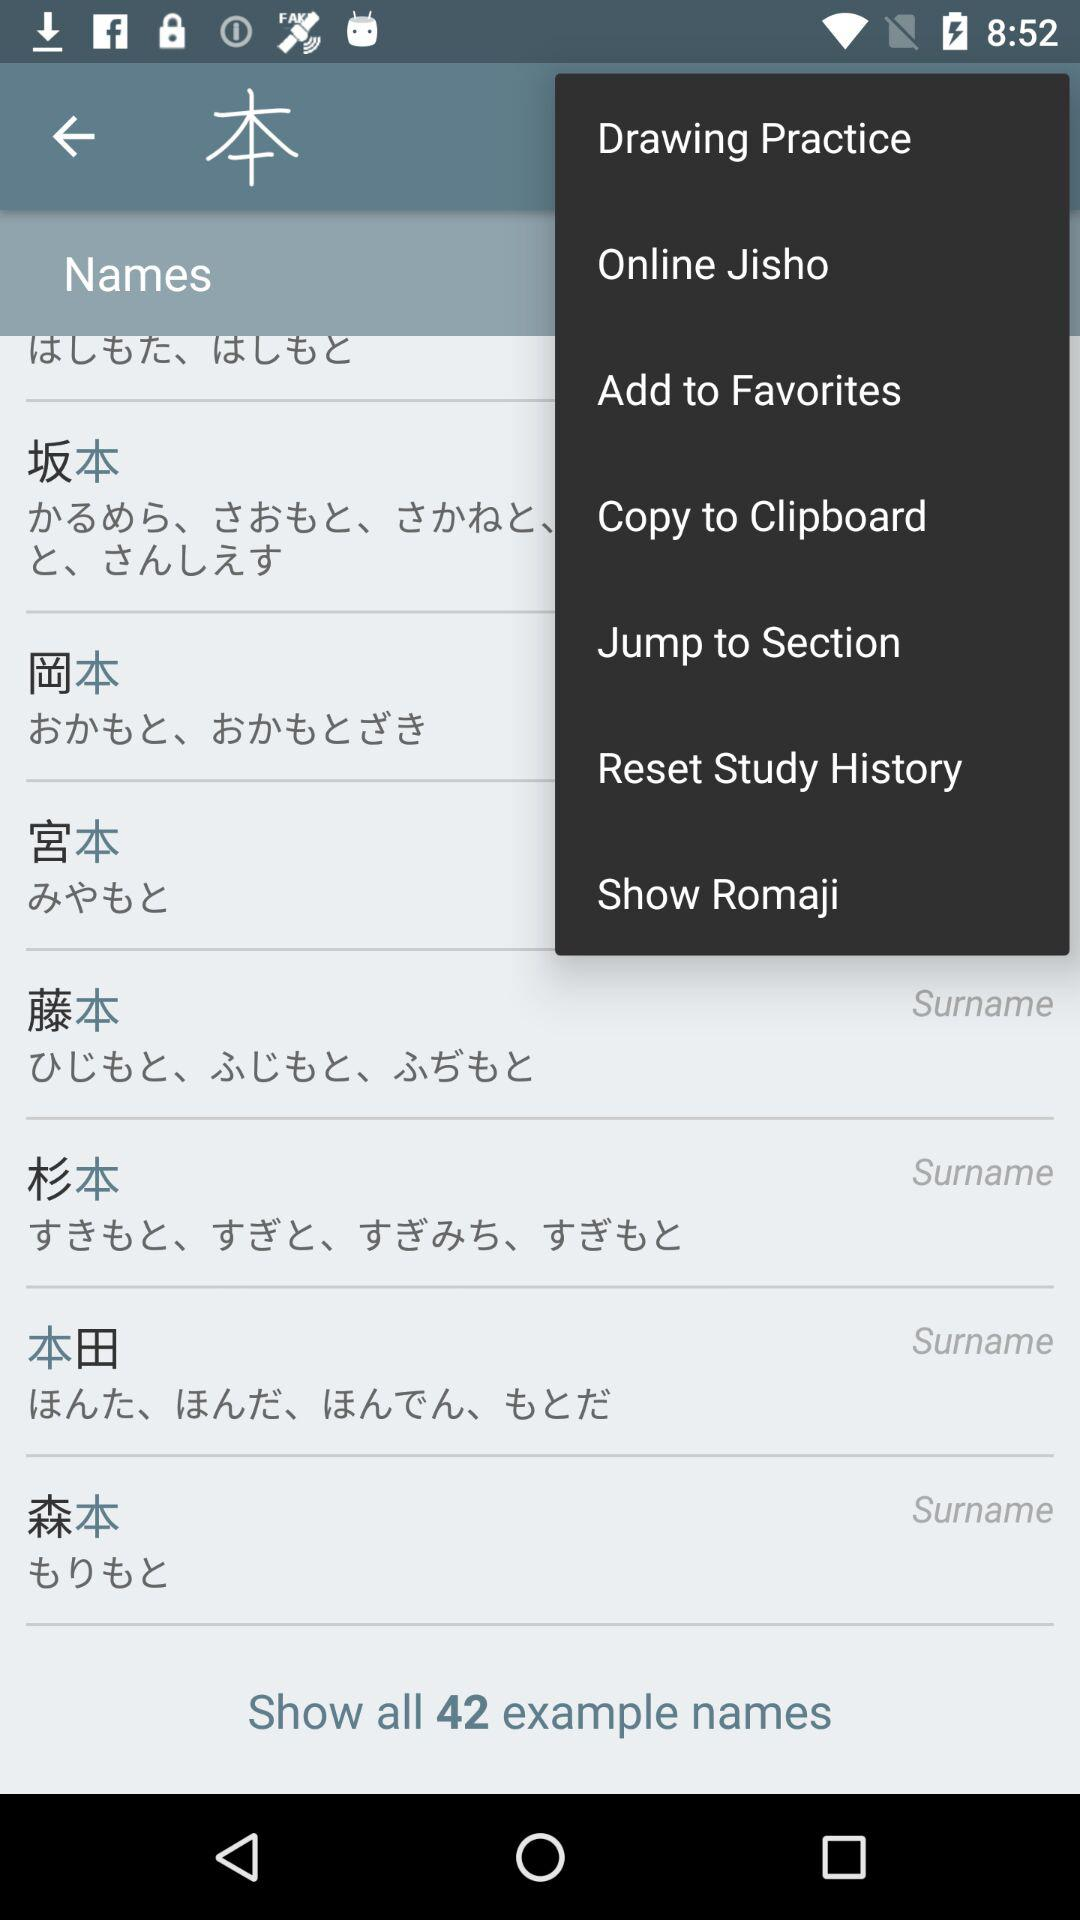How many total example names? There are 42 example names. 